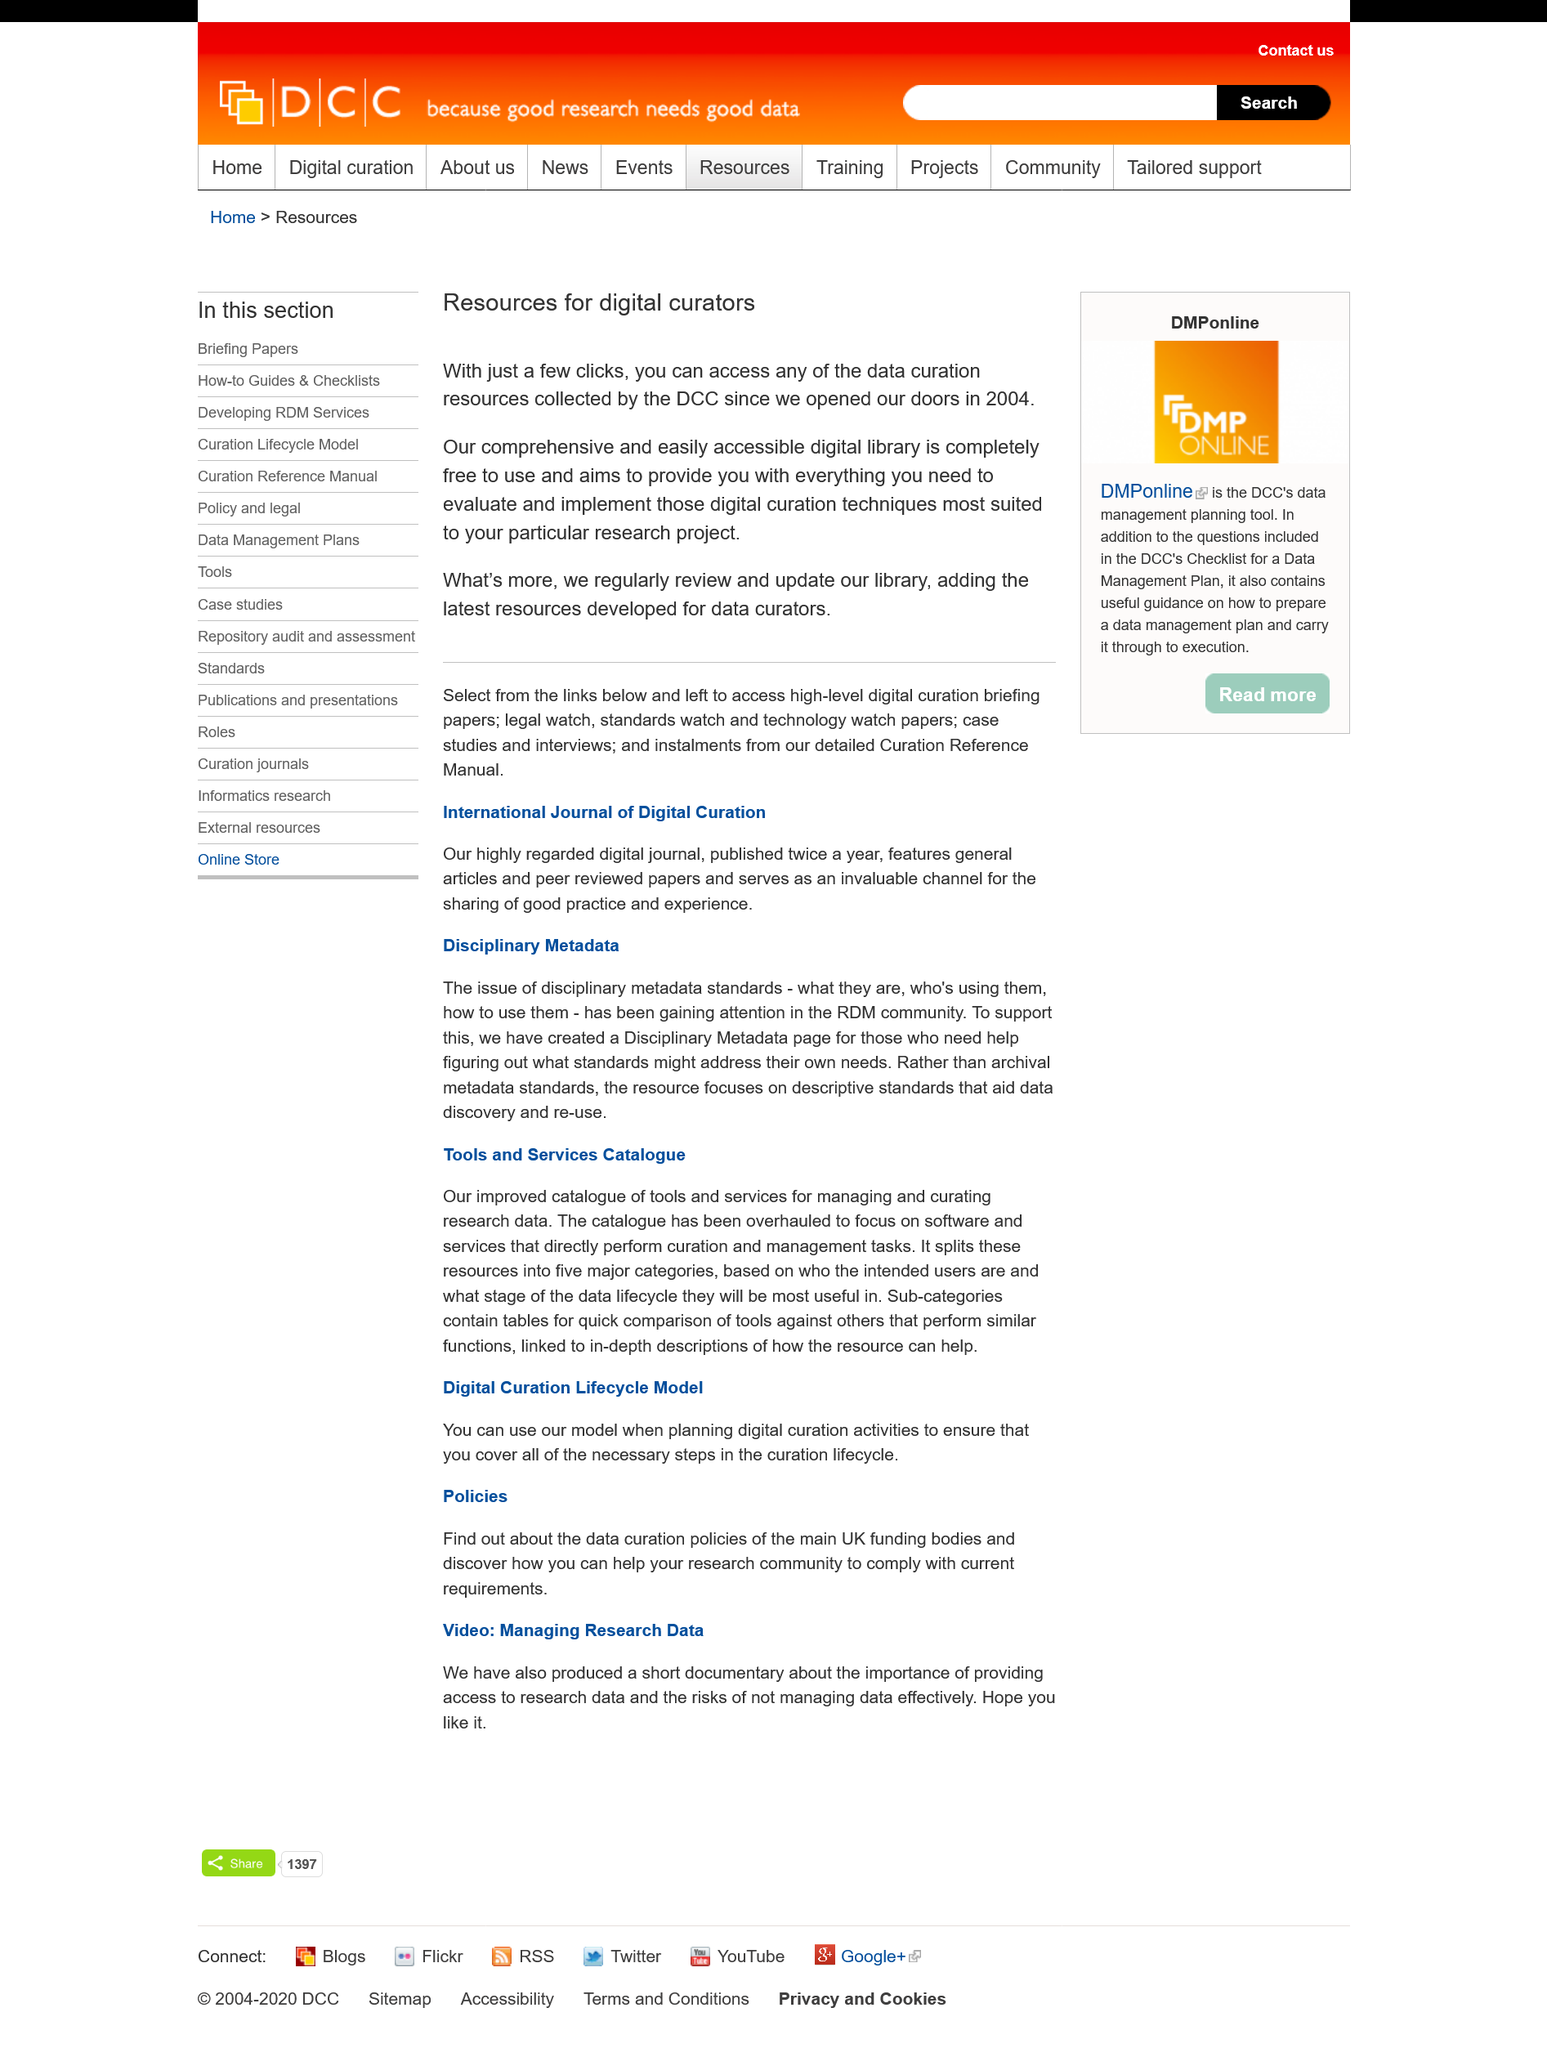Mention a couple of crucial points in this snapshot. The DCC regularly reviews and updates its library. The DCC opened their doors in 2004. The Digital Curation Centre (DCC) has a comprehensive and easily accessible digital library. 